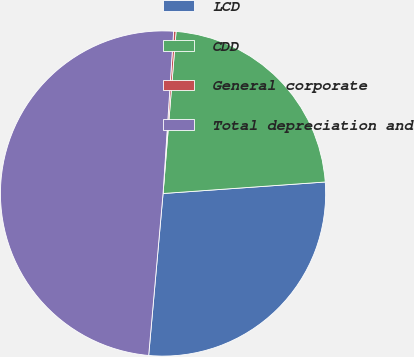Convert chart. <chart><loc_0><loc_0><loc_500><loc_500><pie_chart><fcel>LCD<fcel>CDD<fcel>General corporate<fcel>Total depreciation and<nl><fcel>27.54%<fcel>22.6%<fcel>0.24%<fcel>49.63%<nl></chart> 